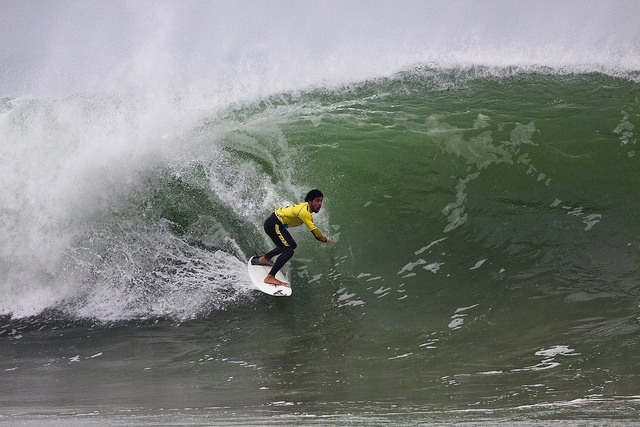Describe the objects in this image and their specific colors. I can see people in darkgray, black, olive, khaki, and maroon tones and surfboard in darkgray, lightgray, black, and gray tones in this image. 